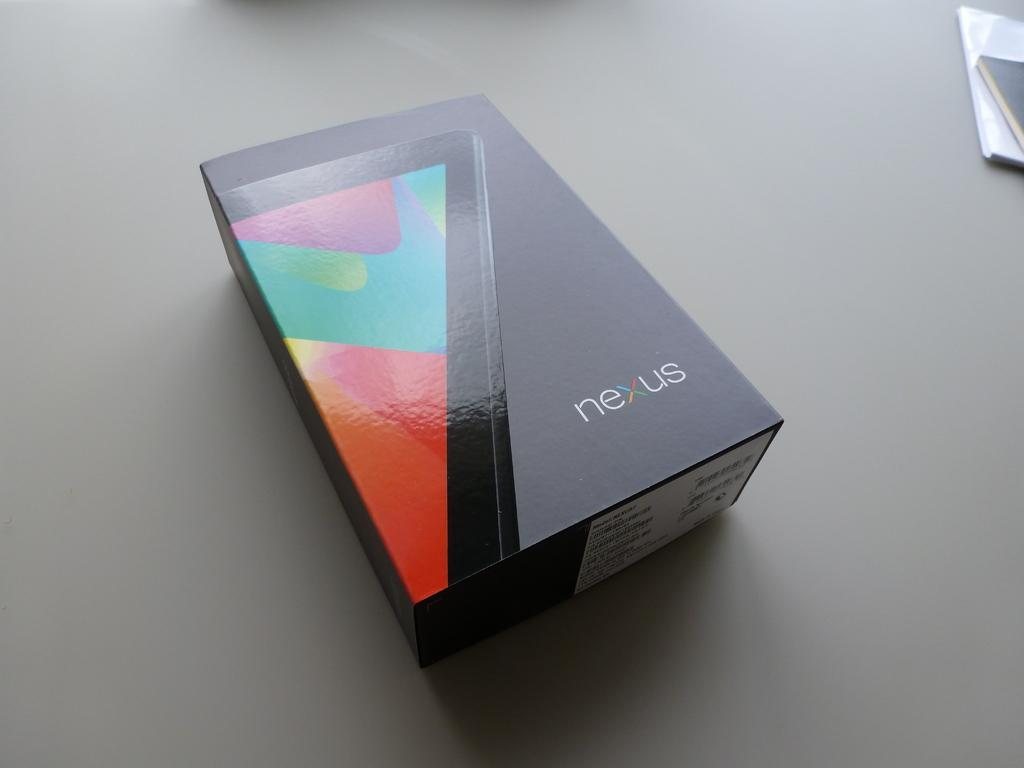What object is on the table in the image? There is a box on the table in the image. What else can be seen on the table? There are books on the table. What type of zinc is present in the image? There is no zinc present in the image. How does the wind affect the objects on the table in the image? There is no wind present in the image, so it cannot affect the objects on the table. 